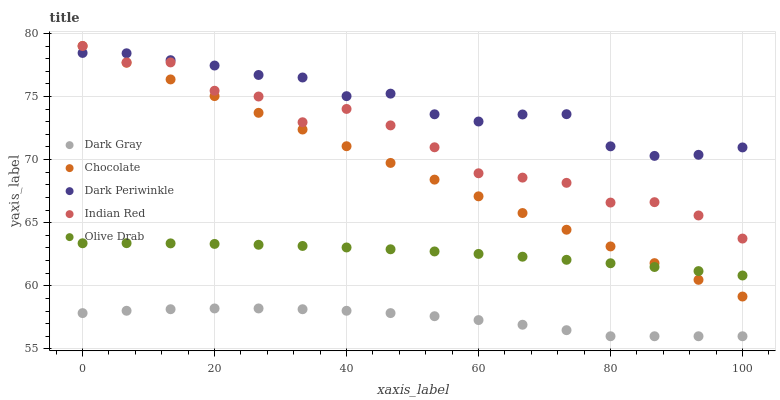Does Dark Gray have the minimum area under the curve?
Answer yes or no. Yes. Does Dark Periwinkle have the maximum area under the curve?
Answer yes or no. Yes. Does Olive Drab have the minimum area under the curve?
Answer yes or no. No. Does Olive Drab have the maximum area under the curve?
Answer yes or no. No. Is Chocolate the smoothest?
Answer yes or no. Yes. Is Indian Red the roughest?
Answer yes or no. Yes. Is Olive Drab the smoothest?
Answer yes or no. No. Is Olive Drab the roughest?
Answer yes or no. No. Does Dark Gray have the lowest value?
Answer yes or no. Yes. Does Olive Drab have the lowest value?
Answer yes or no. No. Does Chocolate have the highest value?
Answer yes or no. Yes. Does Olive Drab have the highest value?
Answer yes or no. No. Is Dark Gray less than Dark Periwinkle?
Answer yes or no. Yes. Is Chocolate greater than Dark Gray?
Answer yes or no. Yes. Does Dark Periwinkle intersect Chocolate?
Answer yes or no. Yes. Is Dark Periwinkle less than Chocolate?
Answer yes or no. No. Is Dark Periwinkle greater than Chocolate?
Answer yes or no. No. Does Dark Gray intersect Dark Periwinkle?
Answer yes or no. No. 